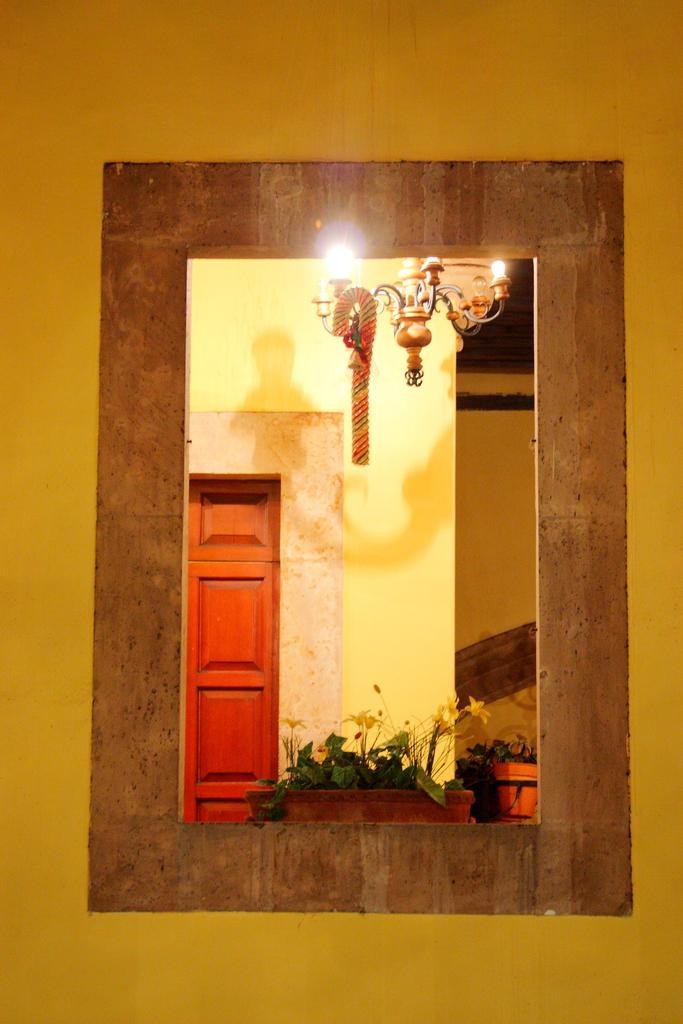What is located in the foreground of the image? There is a wall in the foreground of the image. What feature is present on the wall? There is a window in the wall. What can be seen through the window? A door-like object, a chandelier, and plants are visible through the window. What type of creature is responsible for the death of the plants visible through the window? There is no creature present in the image, and no indication of the plants' health or cause of death. 